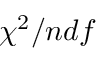<formula> <loc_0><loc_0><loc_500><loc_500>\chi ^ { 2 } / n d f</formula> 